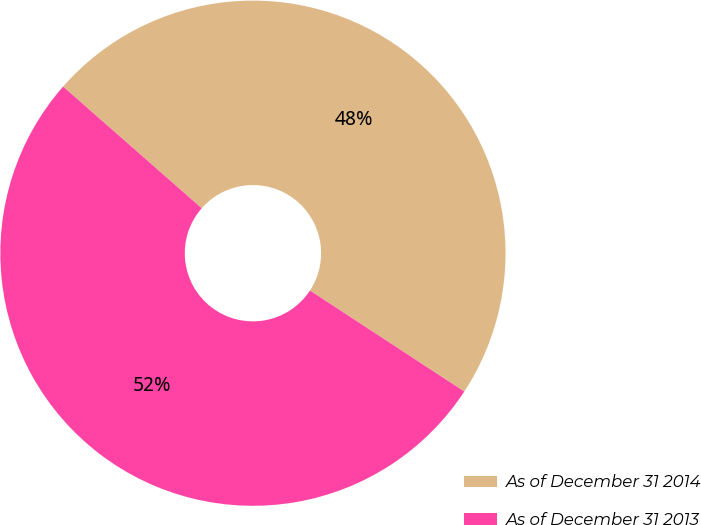Convert chart to OTSL. <chart><loc_0><loc_0><loc_500><loc_500><pie_chart><fcel>As of December 31 2014<fcel>As of December 31 2013<nl><fcel>47.76%<fcel>52.24%<nl></chart> 